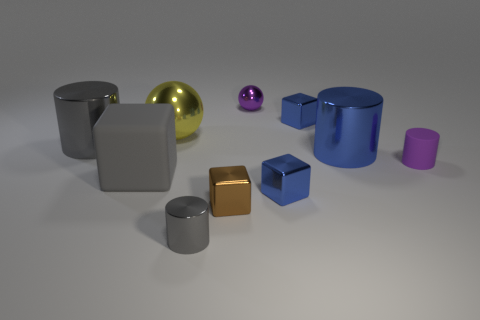Subtract all large gray cubes. How many cubes are left? 3 Subtract all purple spheres. How many blue blocks are left? 2 Subtract all brown blocks. How many blocks are left? 3 Subtract all cubes. How many objects are left? 6 Add 5 big metallic balls. How many big metallic balls are left? 6 Add 8 tiny red things. How many tiny red things exist? 8 Subtract 0 red balls. How many objects are left? 10 Subtract 1 balls. How many balls are left? 1 Subtract all purple spheres. Subtract all brown cylinders. How many spheres are left? 1 Subtract all small gray matte cylinders. Subtract all big gray shiny cylinders. How many objects are left? 9 